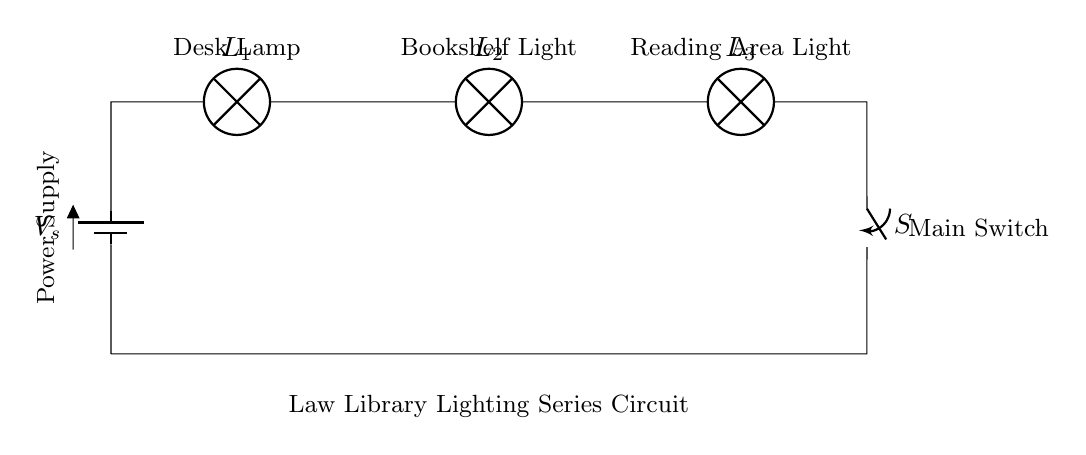What type of circuit is depicted in the diagram? The circuit is a series circuit, as it shows all components connected end to end in a single path for current flow.
Answer: Series circuit What is the total number of lamps in this circuit? The diagram shows three lamps connected in series, indicated by the labels L1, L2, and L3.
Answer: Three What function does the main switch serve in this circuit? The main switch is used to control the flow of current in the circuit, allowing for the entire circuit to be turned on or off.
Answer: Control current If one lamp burns out, what happens to the other lamps? In a series circuit, if one lamp fails, it breaks the circuit, and all other lamps will also go out.
Answer: All go out What is the significance of the power supply in this circuit? The power supply, indicated as Vs, provides the necessary voltage to drive the current through the entire circuit and power the lamps.
Answer: Provides voltage How does the configuration of the lights in this circuit affect the brightness? Since the lamps are in series, the same current flows through each, leading to reduced brightness per lamp compared to a parallel setup.
Answer: Reduced brightness What would happen if the switch is opened? Opening the switch will break the circuit at that point, stopping the flow of current and turning off all lamps connected in series.
Answer: Circuit stops 